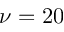<formula> <loc_0><loc_0><loc_500><loc_500>\nu = 2 0</formula> 